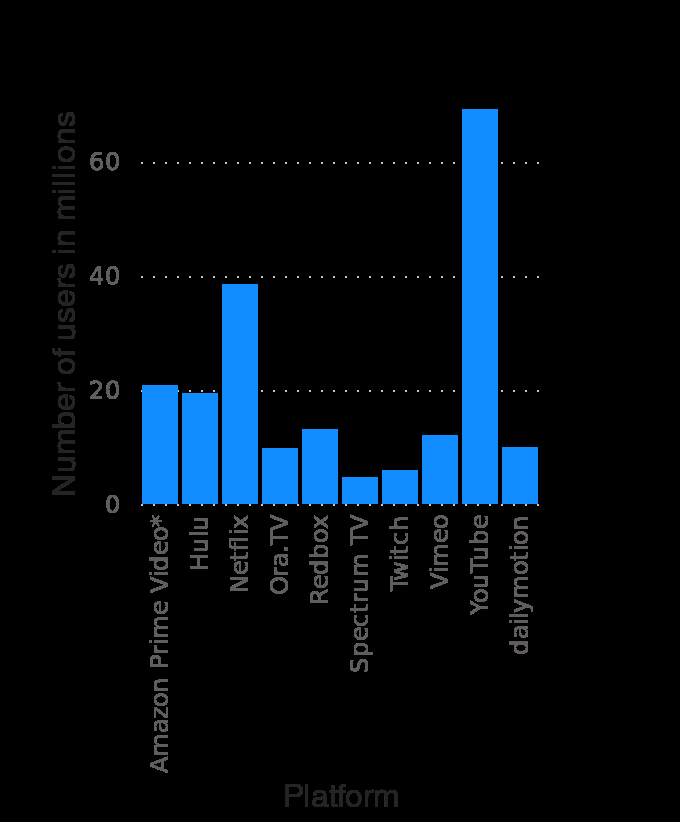<image>
What is the most popular streaming site on mobile in the United States in July 2018?  YouTube What is the range of the y-axis in the bar chart? The range of the y-axis is from 0 to 60 million users. 